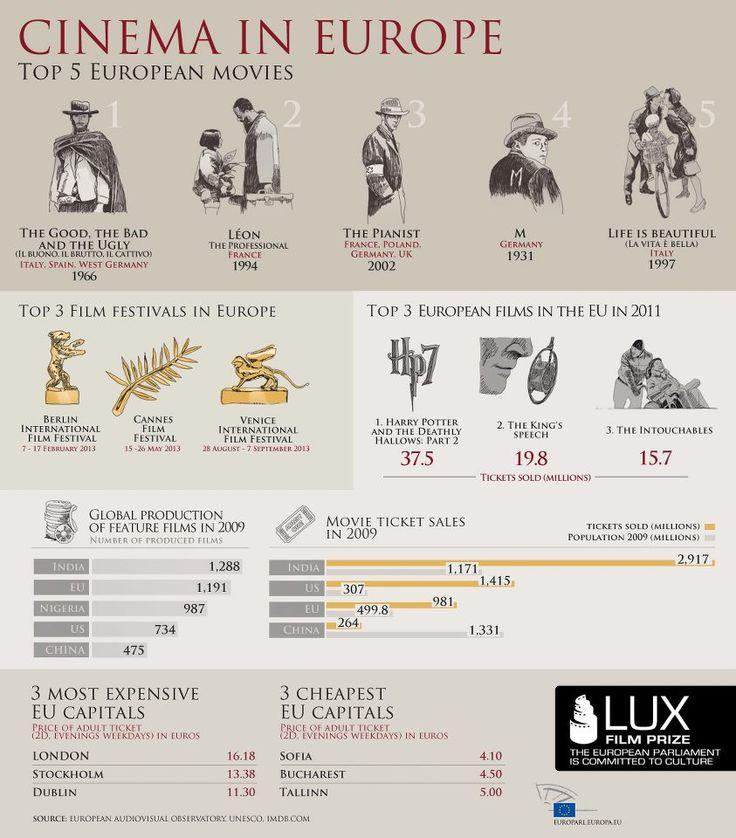Mention a couple of crucial points in this snapshot. According to official records, the movie 'The Intouchables' sold approximately 15.7 million tickets in the European Union in 2011. In the year 2009, a total of 475 films were produced in China. In the year 2009, a total of 1,415 million movie tickets were sold in the United States. The movie 'The King's Speech' sold a total of 19.8 million tickets in the EU in 2011. LIFE IS BEAUTIFUL, which was the top-rated movie released in Italy in the year 1997, is a highly acclaimed film that remains a favorite among audiences to this day. 